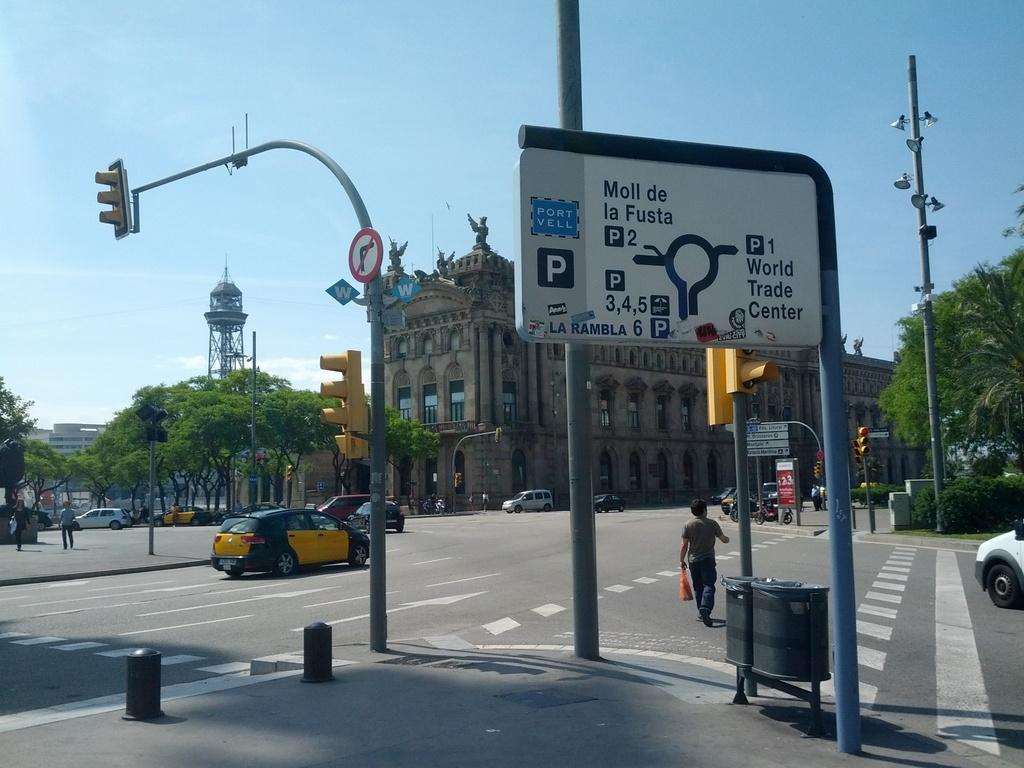<image>
Describe the image concisely. A large sign on the side of a city street shows parking options around the World Trade Center. 